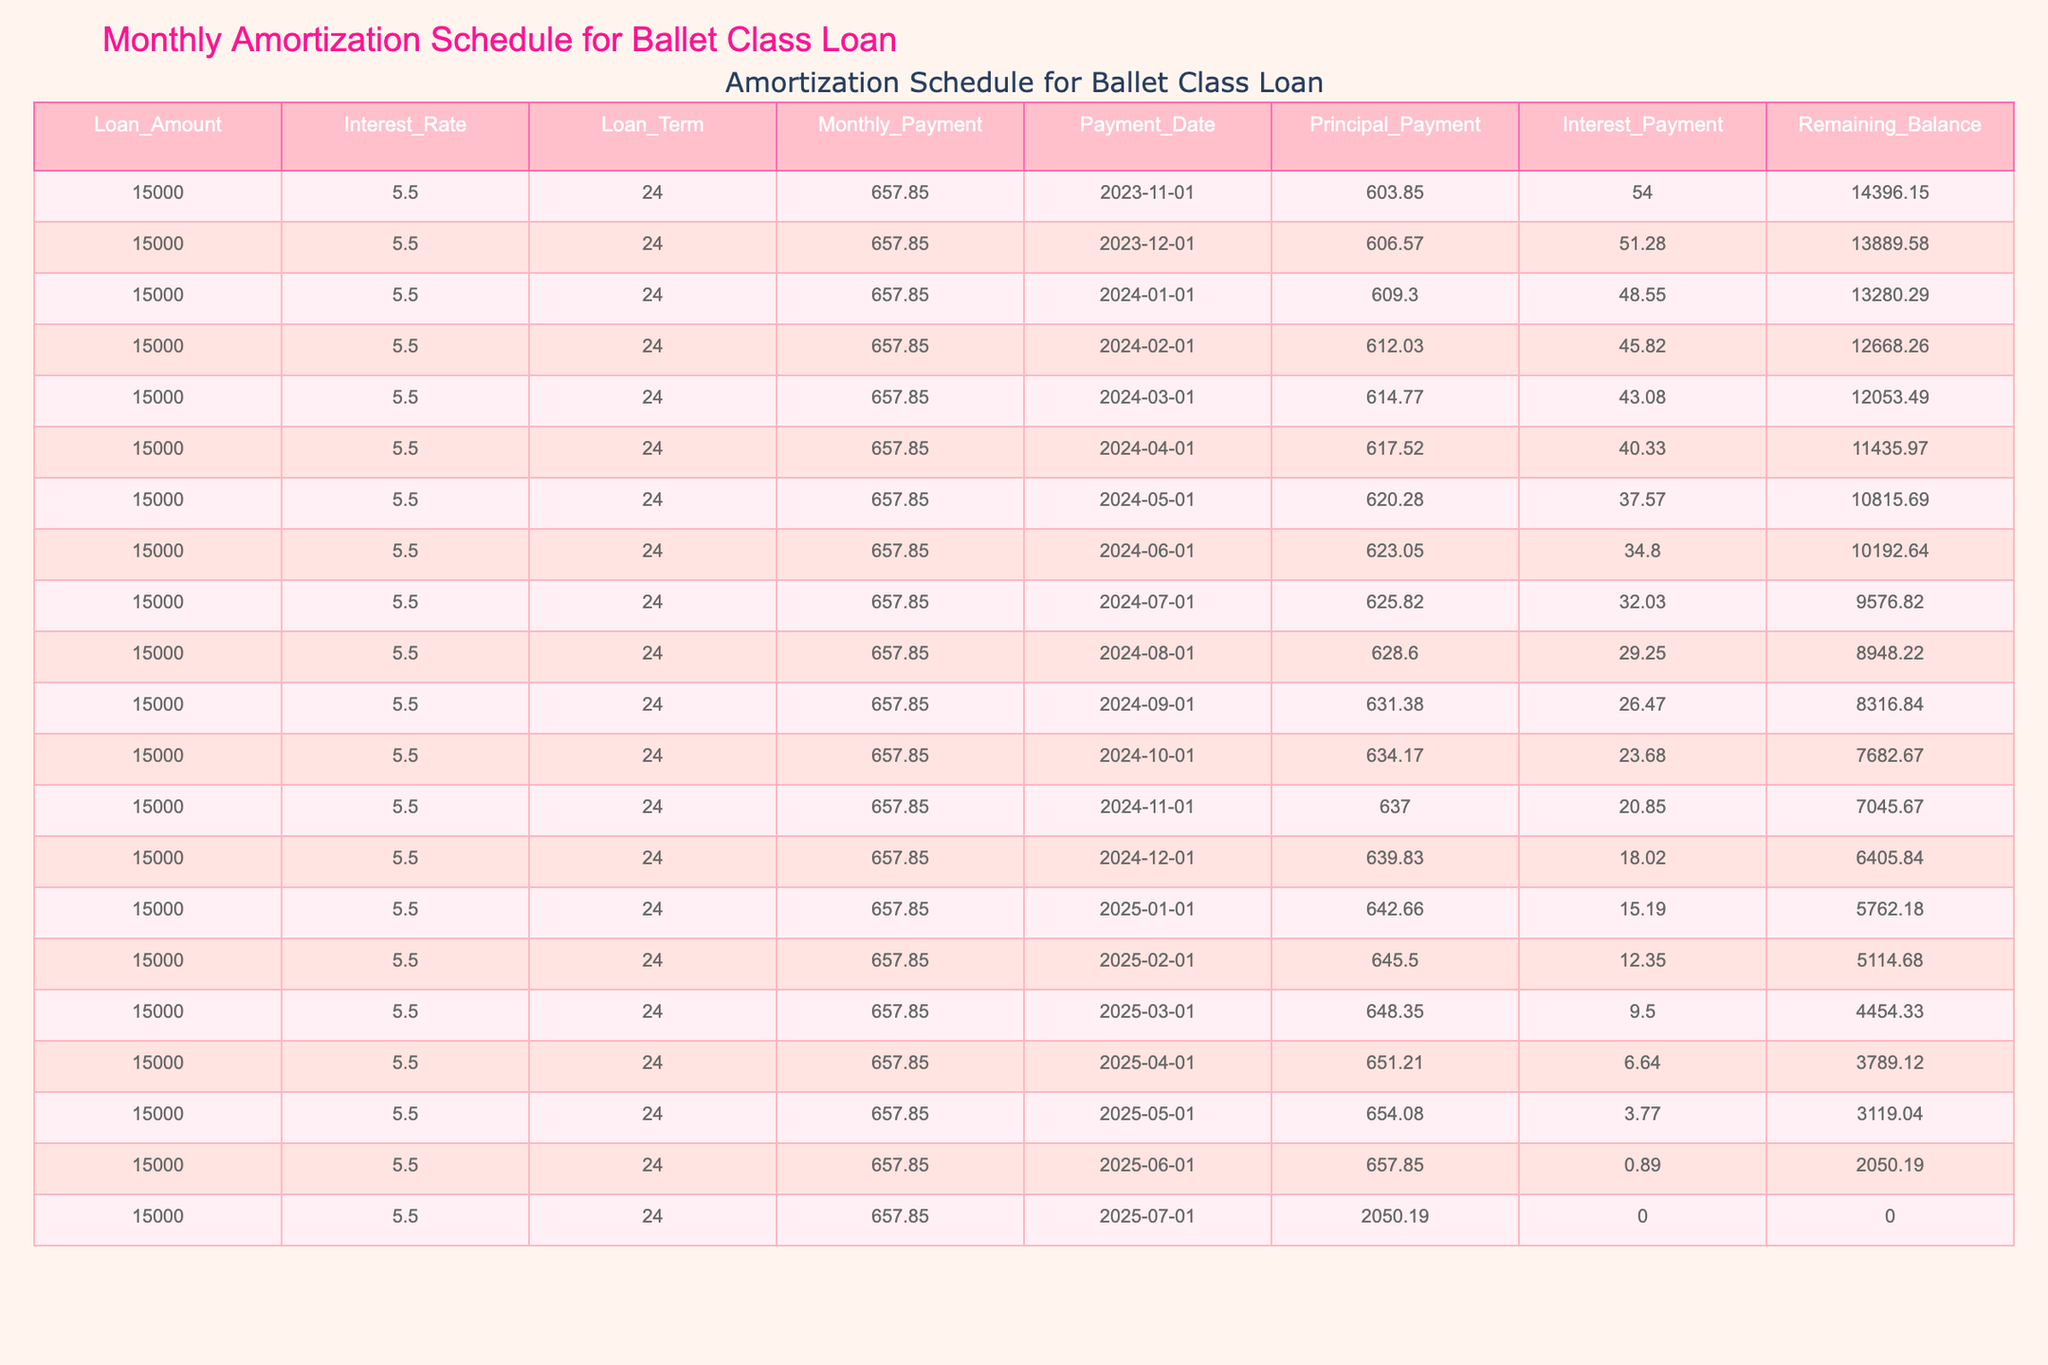What is the total amount of the monthly payments made by the end of January 2024? The monthly payment amount is 657.85. As of January 2024, two payments have been made: one in November 2023 and one in December 2023. Thus, the total amount is (657.85 * 3) = 1973.55.
Answer: 1973.55 What is the interest payment for the first month? In the first month, the interest payment is listed in the table as 54.00.
Answer: 54.00 How much is the remaining balance after the first payment? After the first payment in November 2023, the remaining balance is given as 14396.15 in the table.
Answer: 14396.15 Is the principal payment increasing or decreasing over the loan term? The principal payment starts at 603.85 in the first month and gradually increases each month, as shown in the table, indicating it is increasing.
Answer: Yes What is the average remaining balance during the first 3 months? The remaining balances for the first three months are 14396.15 (November), 13889.58 (December), and 13280.29 (January). The average is calculated as (14396.15 + 13889.58 + 13280.29) / 3 = 13888.67.
Answer: 13888.67 What is the trend of the interest payments over the loan duration? The interest payments start at 54.00 and decrease each month, reaching 0.00 in the final month, indicating a downward trend throughout the loan term.
Answer: Decreasing How much total interest will be paid over the entire loan term? To find the total interest paid, we sum all the monthly interest payments from the table (54.00 + 51.28 + 48.55 + ... + 0.89). Doing the calculation, the total is found to be 835.
Answer: 835 What is the principal payment for the sixth month? Referring to the table, the principal payment for the sixth month, which is April 2024, is noted as 617.52.
Answer: 617.52 How much is the total remaining balance after 6 months? The remaining balance after six months, which corresponds to May 2024, is given in the table as 10815.69.
Answer: 10815.69 